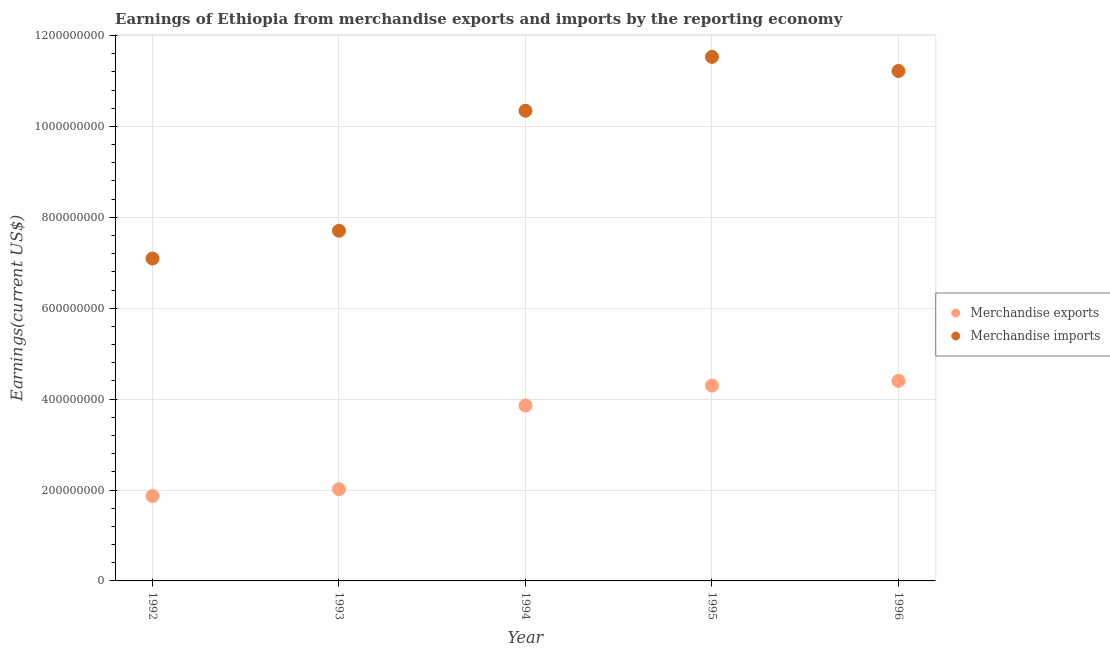Is the number of dotlines equal to the number of legend labels?
Give a very brief answer. Yes. What is the earnings from merchandise exports in 1996?
Your response must be concise. 4.40e+08. Across all years, what is the maximum earnings from merchandise exports?
Give a very brief answer. 4.40e+08. Across all years, what is the minimum earnings from merchandise imports?
Offer a very short reply. 7.09e+08. What is the total earnings from merchandise exports in the graph?
Make the answer very short. 1.64e+09. What is the difference between the earnings from merchandise imports in 1994 and that in 1996?
Offer a very short reply. -8.75e+07. What is the difference between the earnings from merchandise exports in 1992 and the earnings from merchandise imports in 1995?
Your response must be concise. -9.66e+08. What is the average earnings from merchandise exports per year?
Offer a terse response. 3.29e+08. In the year 1995, what is the difference between the earnings from merchandise imports and earnings from merchandise exports?
Your answer should be very brief. 7.23e+08. In how many years, is the earnings from merchandise imports greater than 520000000 US$?
Provide a short and direct response. 5. What is the ratio of the earnings from merchandise imports in 1994 to that in 1995?
Offer a terse response. 0.9. Is the earnings from merchandise exports in 1993 less than that in 1994?
Make the answer very short. Yes. What is the difference between the highest and the second highest earnings from merchandise exports?
Offer a very short reply. 1.04e+07. What is the difference between the highest and the lowest earnings from merchandise imports?
Offer a very short reply. 4.44e+08. Is the sum of the earnings from merchandise exports in 1994 and 1996 greater than the maximum earnings from merchandise imports across all years?
Make the answer very short. No. Is the earnings from merchandise imports strictly greater than the earnings from merchandise exports over the years?
Keep it short and to the point. Yes. Are the values on the major ticks of Y-axis written in scientific E-notation?
Provide a short and direct response. No. Does the graph contain any zero values?
Provide a succinct answer. No. How are the legend labels stacked?
Provide a succinct answer. Vertical. What is the title of the graph?
Ensure brevity in your answer.  Earnings of Ethiopia from merchandise exports and imports by the reporting economy. What is the label or title of the Y-axis?
Provide a succinct answer. Earnings(current US$). What is the Earnings(current US$) in Merchandise exports in 1992?
Your answer should be very brief. 1.87e+08. What is the Earnings(current US$) of Merchandise imports in 1992?
Your answer should be very brief. 7.09e+08. What is the Earnings(current US$) of Merchandise exports in 1993?
Provide a succinct answer. 2.02e+08. What is the Earnings(current US$) of Merchandise imports in 1993?
Keep it short and to the point. 7.70e+08. What is the Earnings(current US$) in Merchandise exports in 1994?
Keep it short and to the point. 3.86e+08. What is the Earnings(current US$) in Merchandise imports in 1994?
Your answer should be very brief. 1.03e+09. What is the Earnings(current US$) in Merchandise exports in 1995?
Ensure brevity in your answer.  4.30e+08. What is the Earnings(current US$) in Merchandise imports in 1995?
Keep it short and to the point. 1.15e+09. What is the Earnings(current US$) of Merchandise exports in 1996?
Your answer should be compact. 4.40e+08. What is the Earnings(current US$) of Merchandise imports in 1996?
Provide a succinct answer. 1.12e+09. Across all years, what is the maximum Earnings(current US$) of Merchandise exports?
Provide a short and direct response. 4.40e+08. Across all years, what is the maximum Earnings(current US$) in Merchandise imports?
Your answer should be very brief. 1.15e+09. Across all years, what is the minimum Earnings(current US$) in Merchandise exports?
Provide a short and direct response. 1.87e+08. Across all years, what is the minimum Earnings(current US$) of Merchandise imports?
Provide a succinct answer. 7.09e+08. What is the total Earnings(current US$) of Merchandise exports in the graph?
Provide a succinct answer. 1.64e+09. What is the total Earnings(current US$) of Merchandise imports in the graph?
Your answer should be compact. 4.79e+09. What is the difference between the Earnings(current US$) of Merchandise exports in 1992 and that in 1993?
Your answer should be very brief. -1.50e+07. What is the difference between the Earnings(current US$) of Merchandise imports in 1992 and that in 1993?
Make the answer very short. -6.11e+07. What is the difference between the Earnings(current US$) in Merchandise exports in 1992 and that in 1994?
Keep it short and to the point. -1.99e+08. What is the difference between the Earnings(current US$) of Merchandise imports in 1992 and that in 1994?
Your answer should be very brief. -3.25e+08. What is the difference between the Earnings(current US$) in Merchandise exports in 1992 and that in 1995?
Provide a succinct answer. -2.43e+08. What is the difference between the Earnings(current US$) of Merchandise imports in 1992 and that in 1995?
Make the answer very short. -4.44e+08. What is the difference between the Earnings(current US$) of Merchandise exports in 1992 and that in 1996?
Offer a very short reply. -2.53e+08. What is the difference between the Earnings(current US$) of Merchandise imports in 1992 and that in 1996?
Keep it short and to the point. -4.13e+08. What is the difference between the Earnings(current US$) in Merchandise exports in 1993 and that in 1994?
Your answer should be compact. -1.84e+08. What is the difference between the Earnings(current US$) in Merchandise imports in 1993 and that in 1994?
Make the answer very short. -2.64e+08. What is the difference between the Earnings(current US$) of Merchandise exports in 1993 and that in 1995?
Provide a succinct answer. -2.28e+08. What is the difference between the Earnings(current US$) in Merchandise imports in 1993 and that in 1995?
Your answer should be compact. -3.83e+08. What is the difference between the Earnings(current US$) in Merchandise exports in 1993 and that in 1996?
Keep it short and to the point. -2.38e+08. What is the difference between the Earnings(current US$) of Merchandise imports in 1993 and that in 1996?
Make the answer very short. -3.51e+08. What is the difference between the Earnings(current US$) of Merchandise exports in 1994 and that in 1995?
Your response must be concise. -4.37e+07. What is the difference between the Earnings(current US$) of Merchandise imports in 1994 and that in 1995?
Offer a terse response. -1.19e+08. What is the difference between the Earnings(current US$) of Merchandise exports in 1994 and that in 1996?
Your response must be concise. -5.41e+07. What is the difference between the Earnings(current US$) in Merchandise imports in 1994 and that in 1996?
Your answer should be compact. -8.75e+07. What is the difference between the Earnings(current US$) in Merchandise exports in 1995 and that in 1996?
Offer a very short reply. -1.04e+07. What is the difference between the Earnings(current US$) of Merchandise imports in 1995 and that in 1996?
Your response must be concise. 3.11e+07. What is the difference between the Earnings(current US$) in Merchandise exports in 1992 and the Earnings(current US$) in Merchandise imports in 1993?
Provide a short and direct response. -5.84e+08. What is the difference between the Earnings(current US$) of Merchandise exports in 1992 and the Earnings(current US$) of Merchandise imports in 1994?
Offer a very short reply. -8.48e+08. What is the difference between the Earnings(current US$) of Merchandise exports in 1992 and the Earnings(current US$) of Merchandise imports in 1995?
Make the answer very short. -9.66e+08. What is the difference between the Earnings(current US$) of Merchandise exports in 1992 and the Earnings(current US$) of Merchandise imports in 1996?
Give a very brief answer. -9.35e+08. What is the difference between the Earnings(current US$) of Merchandise exports in 1993 and the Earnings(current US$) of Merchandise imports in 1994?
Your answer should be compact. -8.33e+08. What is the difference between the Earnings(current US$) of Merchandise exports in 1993 and the Earnings(current US$) of Merchandise imports in 1995?
Your answer should be compact. -9.51e+08. What is the difference between the Earnings(current US$) in Merchandise exports in 1993 and the Earnings(current US$) in Merchandise imports in 1996?
Offer a terse response. -9.20e+08. What is the difference between the Earnings(current US$) in Merchandise exports in 1994 and the Earnings(current US$) in Merchandise imports in 1995?
Keep it short and to the point. -7.67e+08. What is the difference between the Earnings(current US$) in Merchandise exports in 1994 and the Earnings(current US$) in Merchandise imports in 1996?
Make the answer very short. -7.36e+08. What is the difference between the Earnings(current US$) in Merchandise exports in 1995 and the Earnings(current US$) in Merchandise imports in 1996?
Provide a short and direct response. -6.92e+08. What is the average Earnings(current US$) of Merchandise exports per year?
Your answer should be very brief. 3.29e+08. What is the average Earnings(current US$) in Merchandise imports per year?
Provide a succinct answer. 9.58e+08. In the year 1992, what is the difference between the Earnings(current US$) in Merchandise exports and Earnings(current US$) in Merchandise imports?
Make the answer very short. -5.23e+08. In the year 1993, what is the difference between the Earnings(current US$) of Merchandise exports and Earnings(current US$) of Merchandise imports?
Give a very brief answer. -5.69e+08. In the year 1994, what is the difference between the Earnings(current US$) of Merchandise exports and Earnings(current US$) of Merchandise imports?
Make the answer very short. -6.48e+08. In the year 1995, what is the difference between the Earnings(current US$) of Merchandise exports and Earnings(current US$) of Merchandise imports?
Make the answer very short. -7.23e+08. In the year 1996, what is the difference between the Earnings(current US$) of Merchandise exports and Earnings(current US$) of Merchandise imports?
Give a very brief answer. -6.82e+08. What is the ratio of the Earnings(current US$) in Merchandise exports in 1992 to that in 1993?
Your response must be concise. 0.93. What is the ratio of the Earnings(current US$) of Merchandise imports in 1992 to that in 1993?
Offer a very short reply. 0.92. What is the ratio of the Earnings(current US$) in Merchandise exports in 1992 to that in 1994?
Your answer should be very brief. 0.48. What is the ratio of the Earnings(current US$) of Merchandise imports in 1992 to that in 1994?
Your response must be concise. 0.69. What is the ratio of the Earnings(current US$) in Merchandise exports in 1992 to that in 1995?
Ensure brevity in your answer.  0.43. What is the ratio of the Earnings(current US$) in Merchandise imports in 1992 to that in 1995?
Offer a terse response. 0.62. What is the ratio of the Earnings(current US$) in Merchandise exports in 1992 to that in 1996?
Make the answer very short. 0.42. What is the ratio of the Earnings(current US$) in Merchandise imports in 1992 to that in 1996?
Ensure brevity in your answer.  0.63. What is the ratio of the Earnings(current US$) in Merchandise exports in 1993 to that in 1994?
Give a very brief answer. 0.52. What is the ratio of the Earnings(current US$) in Merchandise imports in 1993 to that in 1994?
Make the answer very short. 0.74. What is the ratio of the Earnings(current US$) of Merchandise exports in 1993 to that in 1995?
Offer a very short reply. 0.47. What is the ratio of the Earnings(current US$) in Merchandise imports in 1993 to that in 1995?
Make the answer very short. 0.67. What is the ratio of the Earnings(current US$) in Merchandise exports in 1993 to that in 1996?
Offer a terse response. 0.46. What is the ratio of the Earnings(current US$) in Merchandise imports in 1993 to that in 1996?
Offer a terse response. 0.69. What is the ratio of the Earnings(current US$) of Merchandise exports in 1994 to that in 1995?
Keep it short and to the point. 0.9. What is the ratio of the Earnings(current US$) of Merchandise imports in 1994 to that in 1995?
Provide a short and direct response. 0.9. What is the ratio of the Earnings(current US$) of Merchandise exports in 1994 to that in 1996?
Your answer should be compact. 0.88. What is the ratio of the Earnings(current US$) in Merchandise imports in 1994 to that in 1996?
Your answer should be compact. 0.92. What is the ratio of the Earnings(current US$) in Merchandise exports in 1995 to that in 1996?
Give a very brief answer. 0.98. What is the ratio of the Earnings(current US$) in Merchandise imports in 1995 to that in 1996?
Make the answer very short. 1.03. What is the difference between the highest and the second highest Earnings(current US$) of Merchandise exports?
Provide a succinct answer. 1.04e+07. What is the difference between the highest and the second highest Earnings(current US$) in Merchandise imports?
Offer a terse response. 3.11e+07. What is the difference between the highest and the lowest Earnings(current US$) in Merchandise exports?
Give a very brief answer. 2.53e+08. What is the difference between the highest and the lowest Earnings(current US$) in Merchandise imports?
Your answer should be very brief. 4.44e+08. 